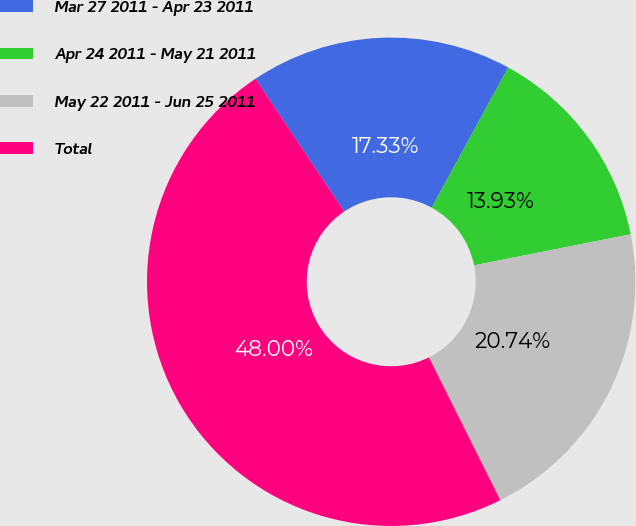<chart> <loc_0><loc_0><loc_500><loc_500><pie_chart><fcel>Mar 27 2011 - Apr 23 2011<fcel>Apr 24 2011 - May 21 2011<fcel>May 22 2011 - Jun 25 2011<fcel>Total<nl><fcel>17.33%<fcel>13.93%<fcel>20.74%<fcel>48.0%<nl></chart> 